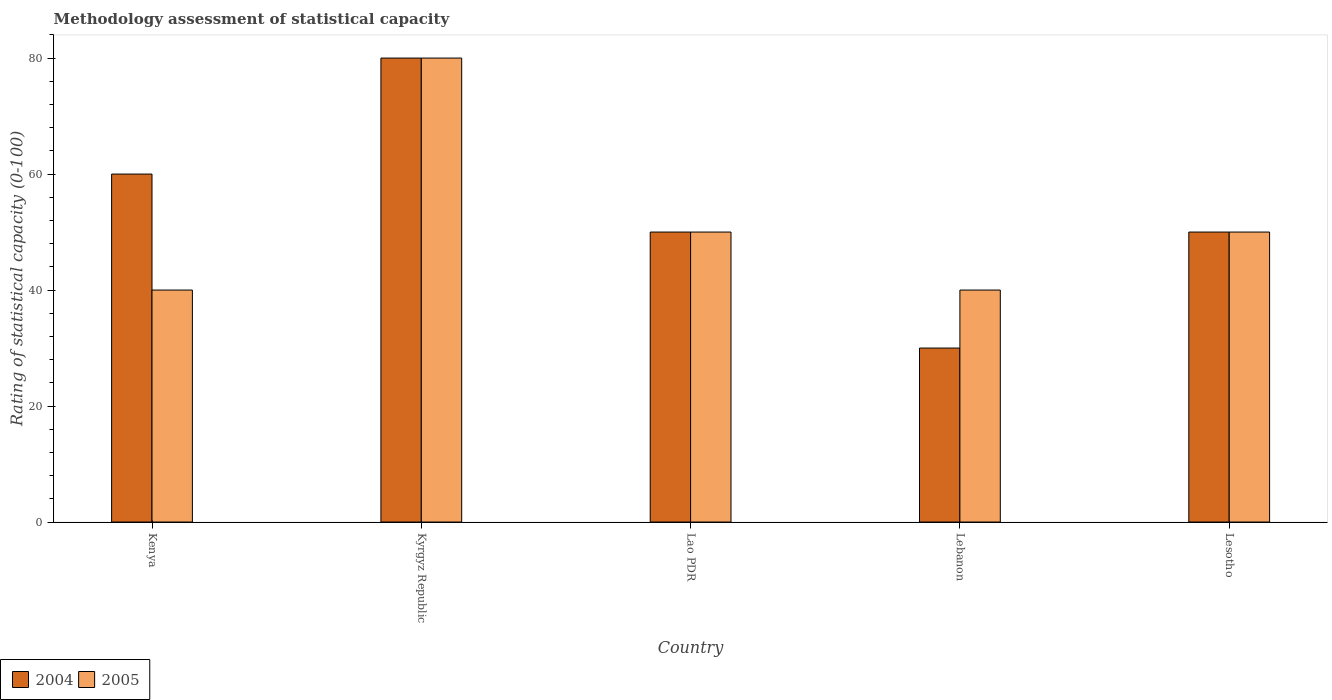How many groups of bars are there?
Your answer should be compact. 5. Are the number of bars per tick equal to the number of legend labels?
Give a very brief answer. Yes. How many bars are there on the 4th tick from the left?
Make the answer very short. 2. How many bars are there on the 1st tick from the right?
Offer a very short reply. 2. What is the label of the 3rd group of bars from the left?
Ensure brevity in your answer.  Lao PDR. What is the rating of statistical capacity in 2005 in Kenya?
Your response must be concise. 40. Across all countries, what is the maximum rating of statistical capacity in 2005?
Make the answer very short. 80. In which country was the rating of statistical capacity in 2004 maximum?
Offer a very short reply. Kyrgyz Republic. In which country was the rating of statistical capacity in 2005 minimum?
Offer a terse response. Kenya. What is the total rating of statistical capacity in 2005 in the graph?
Your answer should be compact. 260. What is the difference between the rating of statistical capacity in 2005 in Lebanon and that in Lesotho?
Provide a short and direct response. -10. What is the difference between the rating of statistical capacity in 2004 in Lebanon and the rating of statistical capacity in 2005 in Lesotho?
Make the answer very short. -20. In how many countries, is the rating of statistical capacity in 2005 greater than 20?
Ensure brevity in your answer.  5. What is the ratio of the rating of statistical capacity in 2004 in Kenya to that in Lao PDR?
Offer a very short reply. 1.2. What is the difference between the highest and the second highest rating of statistical capacity in 2004?
Ensure brevity in your answer.  30. In how many countries, is the rating of statistical capacity in 2004 greater than the average rating of statistical capacity in 2004 taken over all countries?
Give a very brief answer. 2. Is the sum of the rating of statistical capacity in 2004 in Kenya and Lesotho greater than the maximum rating of statistical capacity in 2005 across all countries?
Keep it short and to the point. Yes. What does the 1st bar from the left in Kenya represents?
Make the answer very short. 2004. What does the 2nd bar from the right in Kenya represents?
Your response must be concise. 2004. How many bars are there?
Give a very brief answer. 10. Are the values on the major ticks of Y-axis written in scientific E-notation?
Offer a terse response. No. Where does the legend appear in the graph?
Your response must be concise. Bottom left. How many legend labels are there?
Your answer should be very brief. 2. How are the legend labels stacked?
Give a very brief answer. Horizontal. What is the title of the graph?
Your answer should be very brief. Methodology assessment of statistical capacity. Does "1975" appear as one of the legend labels in the graph?
Ensure brevity in your answer.  No. What is the label or title of the X-axis?
Keep it short and to the point. Country. What is the label or title of the Y-axis?
Your answer should be very brief. Rating of statistical capacity (0-100). What is the Rating of statistical capacity (0-100) of 2004 in Kenya?
Your answer should be compact. 60. What is the Rating of statistical capacity (0-100) in 2005 in Kenya?
Provide a short and direct response. 40. What is the Rating of statistical capacity (0-100) of 2005 in Kyrgyz Republic?
Your answer should be very brief. 80. What is the Rating of statistical capacity (0-100) of 2005 in Lebanon?
Your answer should be very brief. 40. What is the Rating of statistical capacity (0-100) of 2004 in Lesotho?
Ensure brevity in your answer.  50. What is the Rating of statistical capacity (0-100) of 2005 in Lesotho?
Make the answer very short. 50. Across all countries, what is the maximum Rating of statistical capacity (0-100) in 2004?
Offer a very short reply. 80. Across all countries, what is the minimum Rating of statistical capacity (0-100) in 2005?
Provide a succinct answer. 40. What is the total Rating of statistical capacity (0-100) of 2004 in the graph?
Offer a very short reply. 270. What is the total Rating of statistical capacity (0-100) in 2005 in the graph?
Your response must be concise. 260. What is the difference between the Rating of statistical capacity (0-100) in 2005 in Kenya and that in Kyrgyz Republic?
Offer a terse response. -40. What is the difference between the Rating of statistical capacity (0-100) of 2004 in Kenya and that in Lao PDR?
Make the answer very short. 10. What is the difference between the Rating of statistical capacity (0-100) of 2005 in Kenya and that in Lao PDR?
Keep it short and to the point. -10. What is the difference between the Rating of statistical capacity (0-100) of 2004 in Kenya and that in Lebanon?
Keep it short and to the point. 30. What is the difference between the Rating of statistical capacity (0-100) in 2005 in Kenya and that in Lebanon?
Your answer should be compact. 0. What is the difference between the Rating of statistical capacity (0-100) of 2004 in Kenya and that in Lesotho?
Make the answer very short. 10. What is the difference between the Rating of statistical capacity (0-100) in 2004 in Kyrgyz Republic and that in Lao PDR?
Keep it short and to the point. 30. What is the difference between the Rating of statistical capacity (0-100) of 2005 in Kyrgyz Republic and that in Lao PDR?
Offer a terse response. 30. What is the difference between the Rating of statistical capacity (0-100) in 2004 in Kyrgyz Republic and that in Lesotho?
Ensure brevity in your answer.  30. What is the difference between the Rating of statistical capacity (0-100) of 2005 in Kyrgyz Republic and that in Lesotho?
Offer a terse response. 30. What is the difference between the Rating of statistical capacity (0-100) of 2004 in Lao PDR and that in Lesotho?
Offer a terse response. 0. What is the difference between the Rating of statistical capacity (0-100) in 2005 in Lao PDR and that in Lesotho?
Keep it short and to the point. 0. What is the difference between the Rating of statistical capacity (0-100) of 2005 in Lebanon and that in Lesotho?
Offer a very short reply. -10. What is the difference between the Rating of statistical capacity (0-100) in 2004 in Kenya and the Rating of statistical capacity (0-100) in 2005 in Lao PDR?
Keep it short and to the point. 10. What is the difference between the Rating of statistical capacity (0-100) in 2004 in Kenya and the Rating of statistical capacity (0-100) in 2005 in Lebanon?
Provide a short and direct response. 20. What is the difference between the Rating of statistical capacity (0-100) of 2004 in Kyrgyz Republic and the Rating of statistical capacity (0-100) of 2005 in Lebanon?
Provide a short and direct response. 40. What is the difference between the Rating of statistical capacity (0-100) of 2004 in Lao PDR and the Rating of statistical capacity (0-100) of 2005 in Lebanon?
Keep it short and to the point. 10. What is the difference between the Rating of statistical capacity (0-100) of 2004 in Lebanon and the Rating of statistical capacity (0-100) of 2005 in Lesotho?
Offer a terse response. -20. What is the average Rating of statistical capacity (0-100) in 2005 per country?
Your answer should be very brief. 52. What is the difference between the Rating of statistical capacity (0-100) of 2004 and Rating of statistical capacity (0-100) of 2005 in Kenya?
Keep it short and to the point. 20. What is the difference between the Rating of statistical capacity (0-100) in 2004 and Rating of statistical capacity (0-100) in 2005 in Lao PDR?
Offer a terse response. 0. What is the difference between the Rating of statistical capacity (0-100) of 2004 and Rating of statistical capacity (0-100) of 2005 in Lesotho?
Offer a terse response. 0. What is the ratio of the Rating of statistical capacity (0-100) in 2004 in Kenya to that in Kyrgyz Republic?
Offer a very short reply. 0.75. What is the ratio of the Rating of statistical capacity (0-100) of 2004 in Kenya to that in Lao PDR?
Offer a terse response. 1.2. What is the ratio of the Rating of statistical capacity (0-100) in 2005 in Kenya to that in Lao PDR?
Ensure brevity in your answer.  0.8. What is the ratio of the Rating of statistical capacity (0-100) in 2005 in Kyrgyz Republic to that in Lao PDR?
Give a very brief answer. 1.6. What is the ratio of the Rating of statistical capacity (0-100) of 2004 in Kyrgyz Republic to that in Lebanon?
Provide a short and direct response. 2.67. What is the ratio of the Rating of statistical capacity (0-100) in 2005 in Kyrgyz Republic to that in Lebanon?
Provide a short and direct response. 2. What is the ratio of the Rating of statistical capacity (0-100) in 2005 in Kyrgyz Republic to that in Lesotho?
Provide a short and direct response. 1.6. What is the ratio of the Rating of statistical capacity (0-100) in 2004 in Lao PDR to that in Lesotho?
Keep it short and to the point. 1. What is the ratio of the Rating of statistical capacity (0-100) of 2005 in Lao PDR to that in Lesotho?
Offer a very short reply. 1. What is the difference between the highest and the second highest Rating of statistical capacity (0-100) in 2004?
Your answer should be compact. 20. What is the difference between the highest and the lowest Rating of statistical capacity (0-100) in 2004?
Your answer should be very brief. 50. 